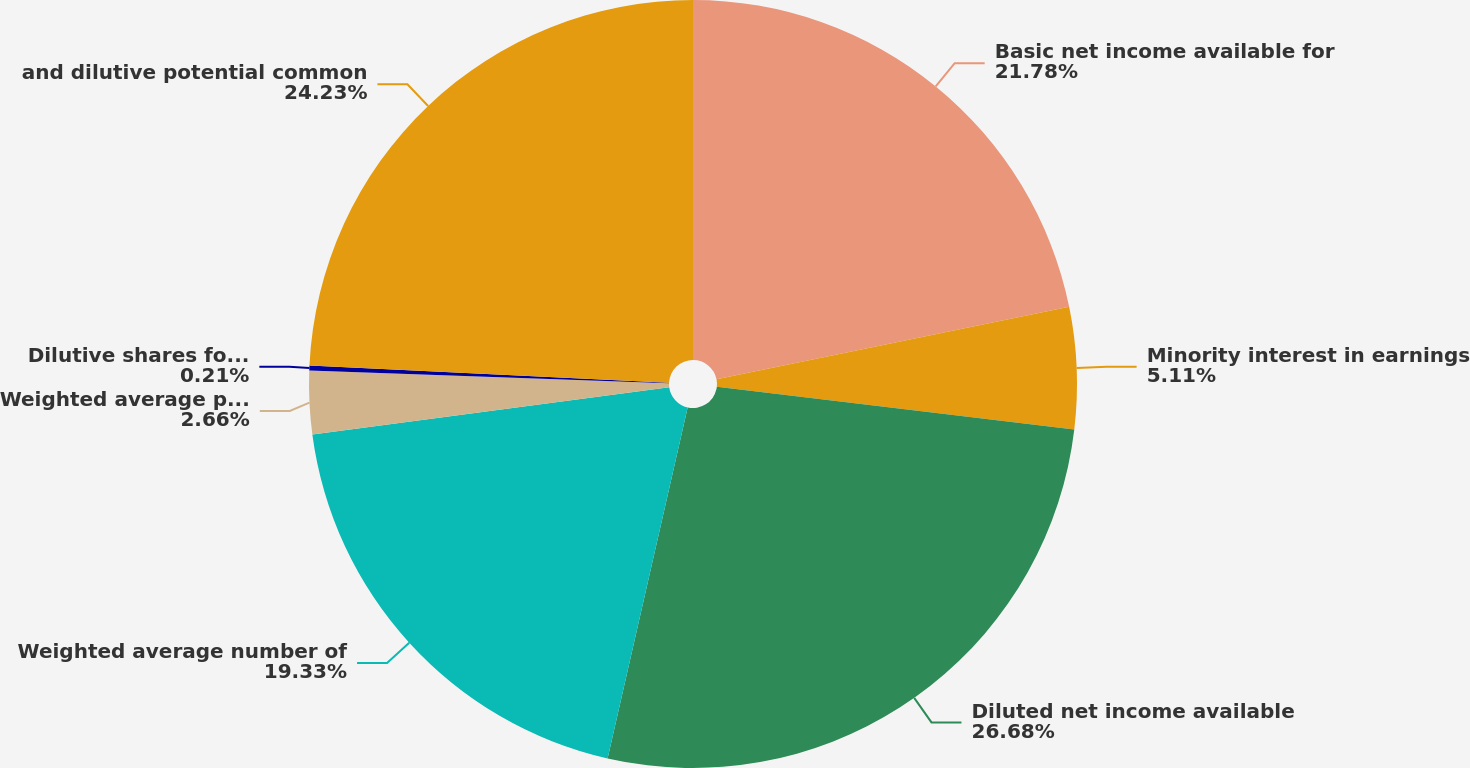Convert chart. <chart><loc_0><loc_0><loc_500><loc_500><pie_chart><fcel>Basic net income available for<fcel>Minority interest in earnings<fcel>Diluted net income available<fcel>Weighted average number of<fcel>Weighted average partnership<fcel>Dilutive shares for long-term<fcel>and dilutive potential common<nl><fcel>21.78%<fcel>5.11%<fcel>26.68%<fcel>19.33%<fcel>2.66%<fcel>0.21%<fcel>24.23%<nl></chart> 